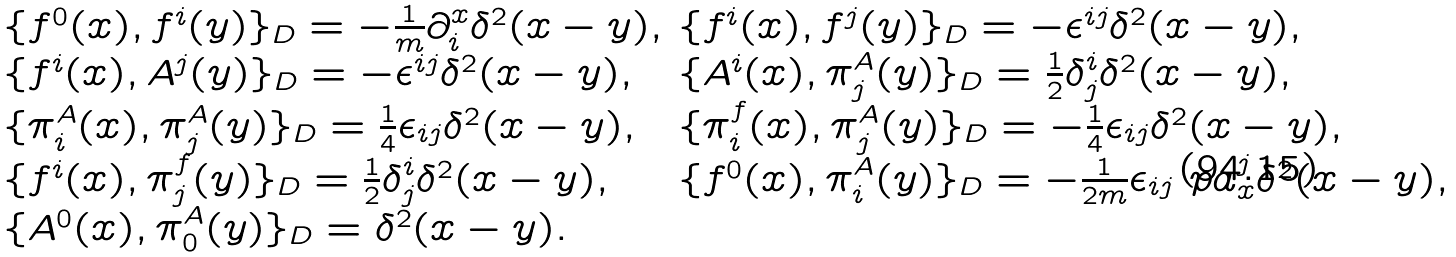Convert formula to latex. <formula><loc_0><loc_0><loc_500><loc_500>\begin{array} { l l } \{ f ^ { 0 } ( x ) , f ^ { i } ( y ) \} _ { D } = - \frac { 1 } { m } \partial ^ { x } _ { i } \delta ^ { 2 } ( x - y ) , & \{ f ^ { i } ( x ) , f ^ { j } ( y ) \} _ { D } = - \epsilon ^ { i j } \delta ^ { 2 } ( x - y ) , \\ \{ f ^ { i } ( x ) , A ^ { j } ( y ) \} _ { D } = - \epsilon ^ { i j } \delta ^ { 2 } ( x - y ) , & \{ A ^ { i } ( x ) , \pi _ { j } ^ { A } ( y ) \} _ { D } = \frac { 1 } { 2 } \delta ^ { i } _ { j } \delta ^ { 2 } ( x - y ) , \\ \{ \pi _ { i } ^ { A } ( x ) , \pi _ { j } ^ { A } ( y ) \} _ { D } = \frac { 1 } { 4 } \epsilon _ { i j } \delta ^ { 2 } ( x - y ) , & \{ \pi _ { i } ^ { f } ( x ) , \pi _ { j } ^ { A } ( y ) \} _ { D } = - \frac { 1 } { 4 } \epsilon _ { i j } \delta ^ { 2 } ( x - y ) , \\ \{ f ^ { i } ( x ) , \pi _ { j } ^ { f } ( y ) \} _ { D } = \frac { 1 } { 2 } \delta ^ { i } _ { j } \delta ^ { 2 } ( x - y ) , & \{ f ^ { 0 } ( x ) , \pi _ { i } ^ { A } ( y ) \} _ { D } = - \frac { 1 } { 2 m } \epsilon _ { i j } \ p a ^ { j } _ { x } \delta ^ { 2 } ( x - y ) , \\ \{ A ^ { 0 } ( x ) , \pi _ { 0 } ^ { A } ( y ) \} _ { D } = \delta ^ { 2 } ( x - y ) . & \end{array}</formula> 